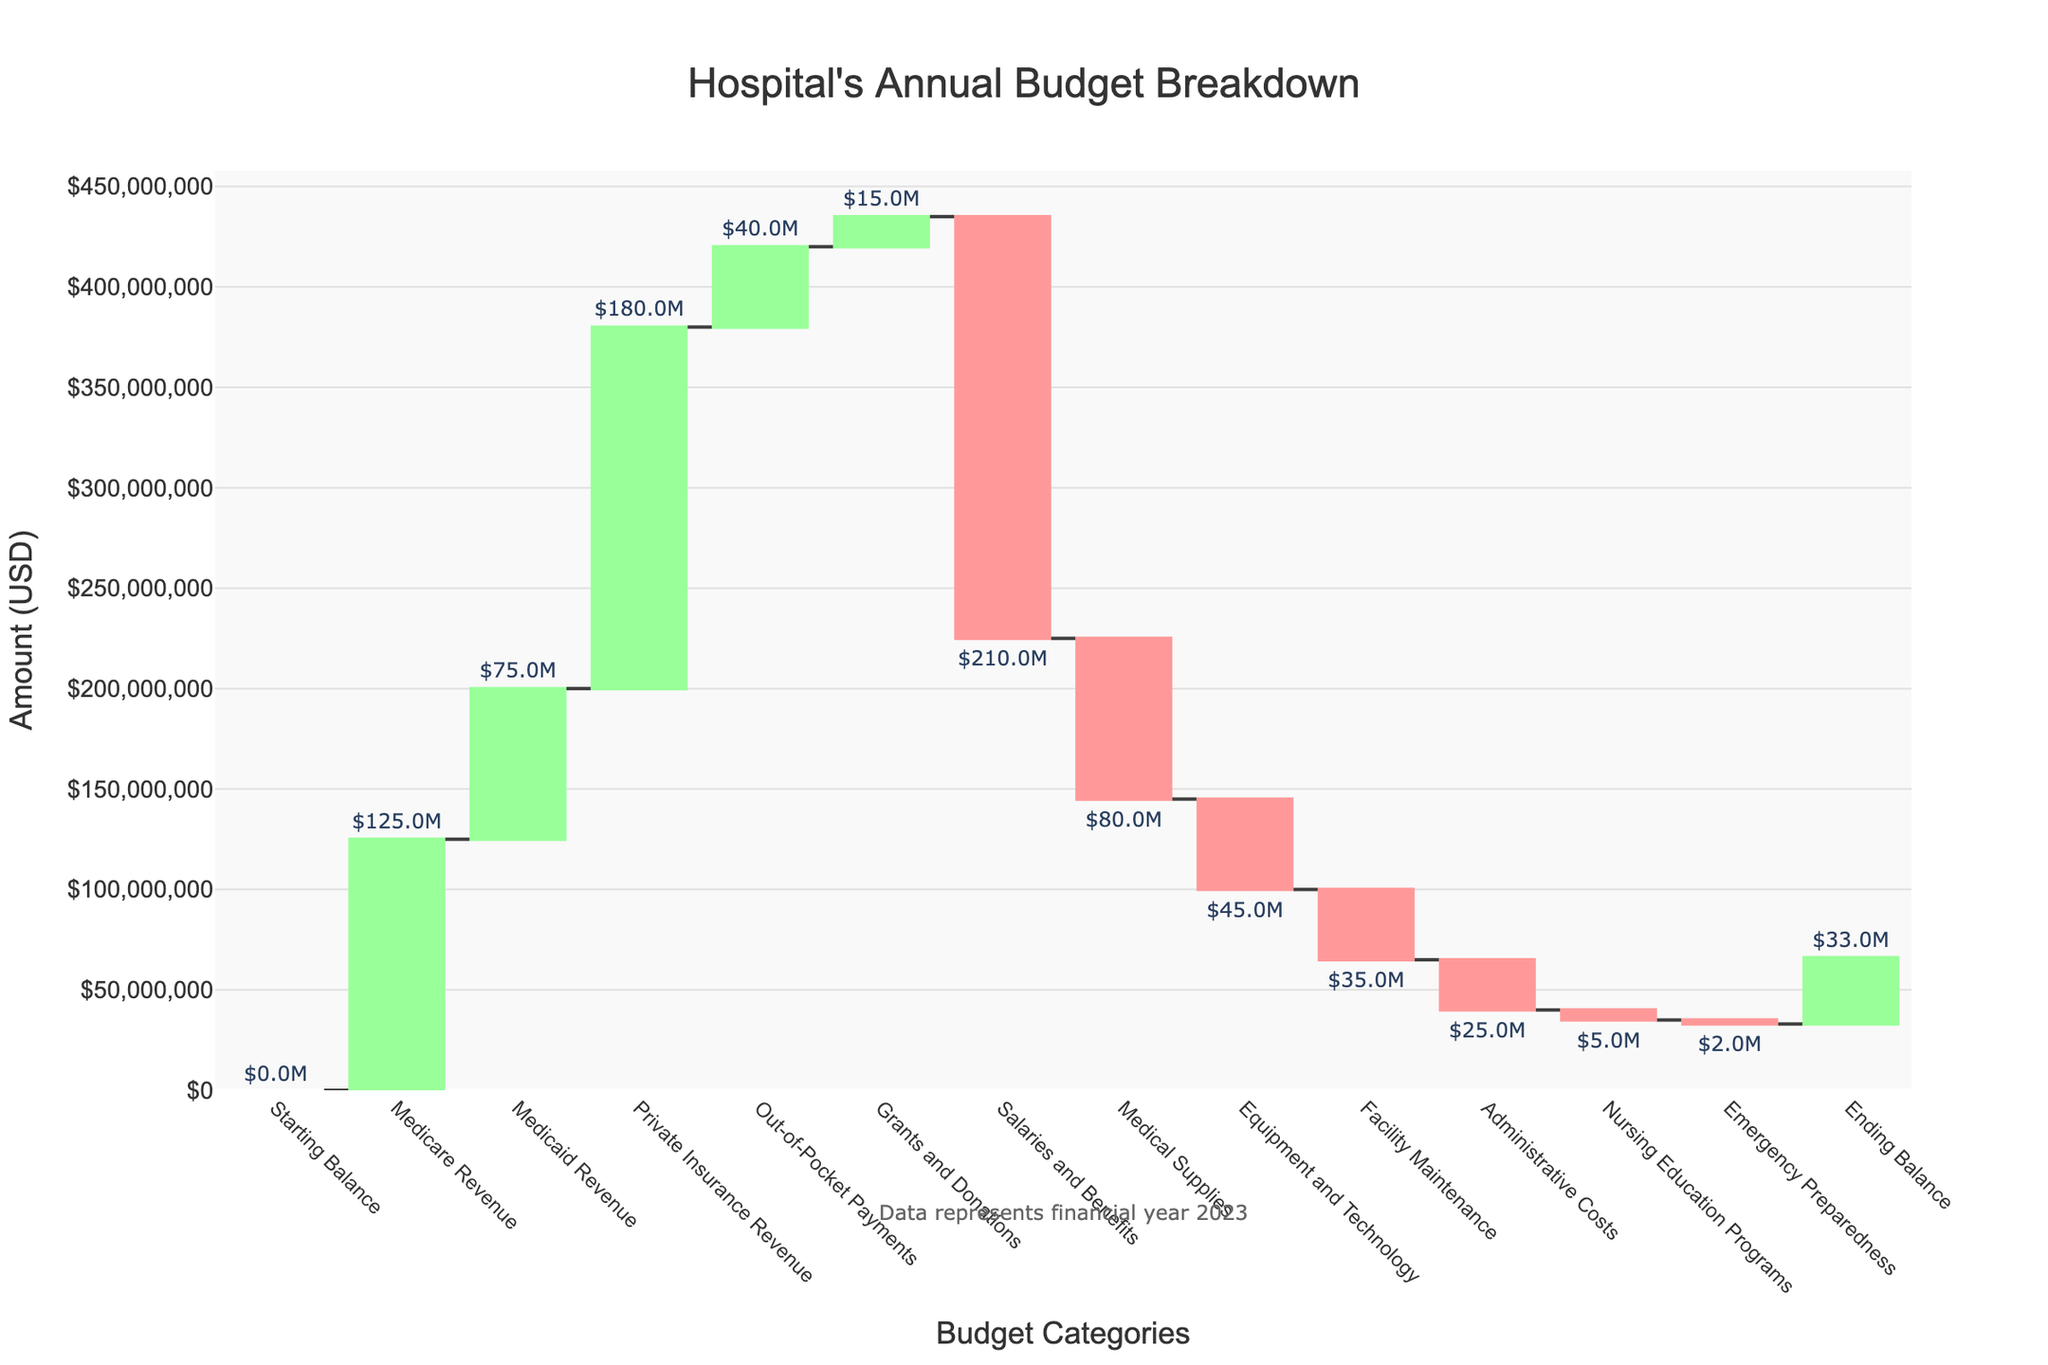What is the title of the chart? The title of the chart is displayed prominently at the top of the chart, typically in a larger font size for easy visibility.
Answer: Hospital's Annual Budget Breakdown What does the y-axis represent in this chart? The y-axis represents the amount in USD, which shows the financial values for various categories in the hospital's budget. This is indicated by the title on the y-axis.
Answer: Amount (USD) Which category has the highest revenue in the chart? To find the highest revenue category, compare all the positive values. Private Insurance Revenue shows the highest value.
Answer: Private Insurance Revenue How much is spent on Salaries and Benefits? Locate the Salaries and Benefits entry and observe its value, which is displayed visually as a bar. The value is also indicated with text outside the bar.
Answer: -210000000 What is the total revenue from Medicare and Medicaid? Sum the values for Medicare Revenue and Medicaid Revenue: 125,000,000 + 75,000,000 = 200,000,000.
Answer: 200,000,000 What is the ending balance for the hospital? Find the Ending Balance category and look at its value, which is explicitly mentioned.
Answer: 33,000,000 How does the expense of Equipment and Technology compare to Medical Supplies? Compare the values for Equipment and Technology and Medical Supplies. The specific values are -45,000,000 for Equipment and Technology and -80,000,000 for Medical Supplies. Equipment and Technology is less than Medical Supplies.
Answer: Equipment and Technology is less than Medical Supplies What are the two smallest expenses in the hospital's budget? Review the values in the negative categories. The smallest expenses are Nursing Education Programs (-5,000,000) and Emergency Preparedness (-2,000,000).
Answer: Nursing Education Programs and Emergency Preparedness Which categories are classified under expenses? Identify the categories with negative values. These are Salaries and Benefits, Medical Supplies, Equipment and Technology, Facility Maintenance, Administrative Costs, Nursing Education Programs, and Emergency Preparedness.
Answer: Salaries and Benefits, Medical Supplies, Equipment and Technology, Facility Maintenance, Administrative Costs, Nursing Education Programs, Emergency Preparedness What is the total amount of revenue generated from all sources combined? Add the values of all positive amounts (Medicare Revenue, Medicaid Revenue, Private Insurance Revenue, Out-of-Pocket Payments, Grants and Donations): 125,000,000 + 75,000,000 + 180,000,000 + 40,000,000 + 15,000,000 = 435,000,000.
Answer: 435,000,000 